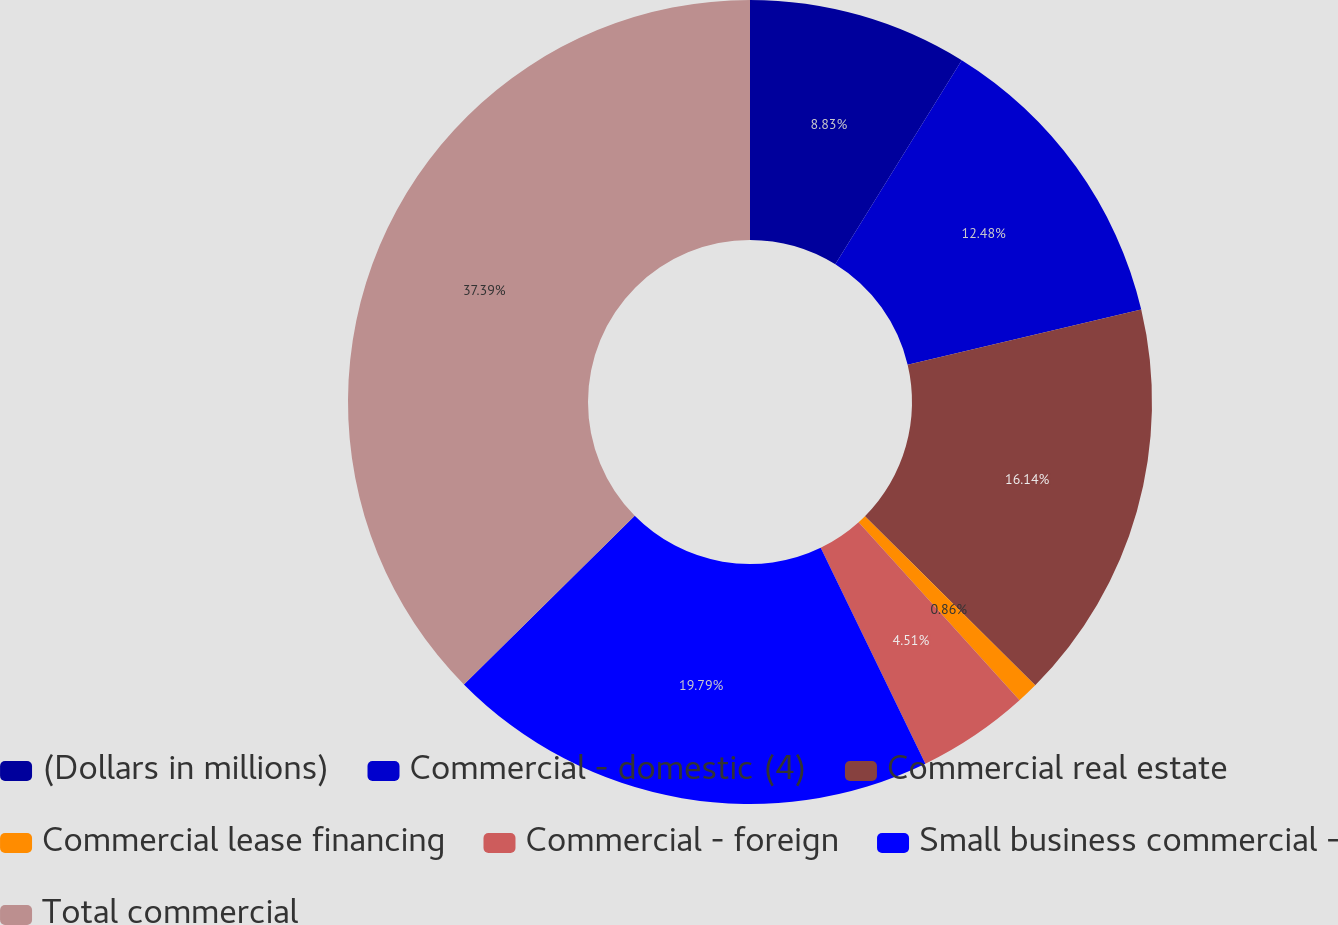Convert chart. <chart><loc_0><loc_0><loc_500><loc_500><pie_chart><fcel>(Dollars in millions)<fcel>Commercial - domestic (4)<fcel>Commercial real estate<fcel>Commercial lease financing<fcel>Commercial - foreign<fcel>Small business commercial -<fcel>Total commercial<nl><fcel>8.83%<fcel>12.48%<fcel>16.14%<fcel>0.86%<fcel>4.51%<fcel>19.79%<fcel>37.4%<nl></chart> 